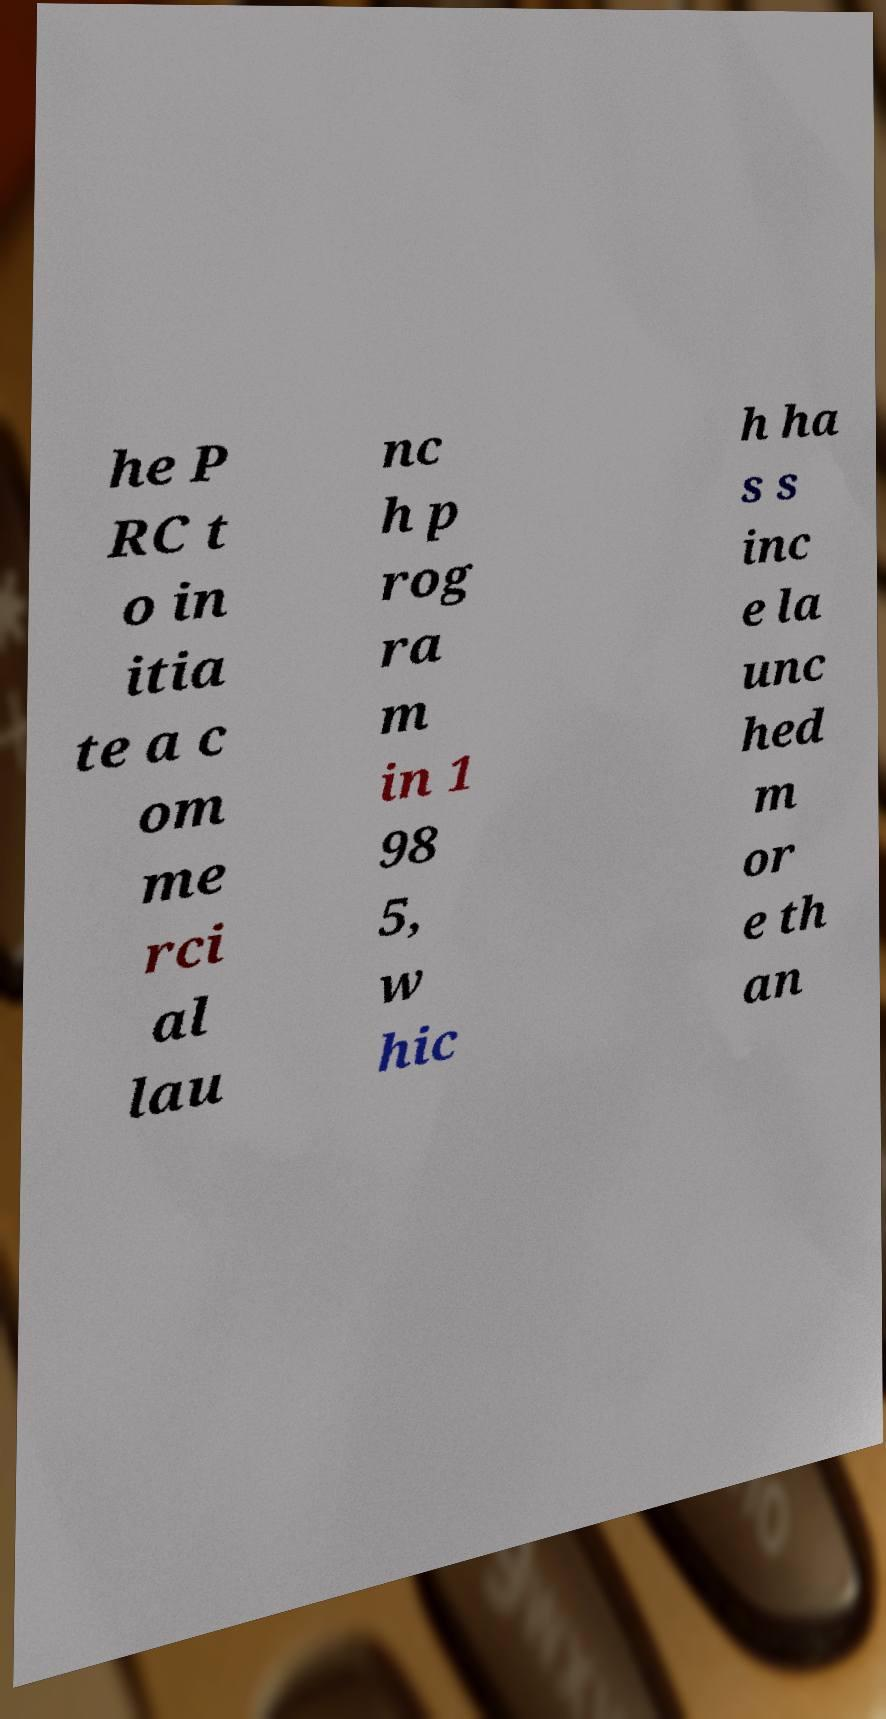For documentation purposes, I need the text within this image transcribed. Could you provide that? he P RC t o in itia te a c om me rci al lau nc h p rog ra m in 1 98 5, w hic h ha s s inc e la unc hed m or e th an 